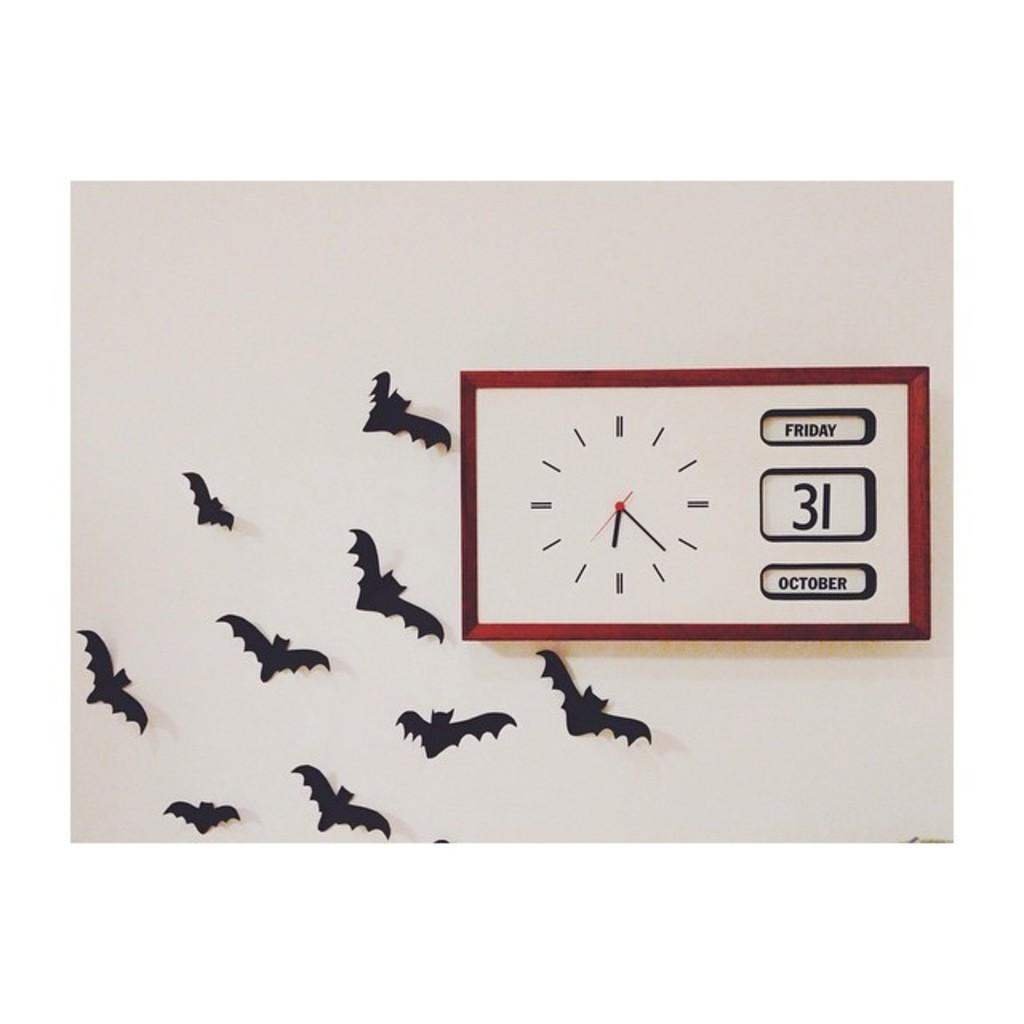<image>
Provide a brief description of the given image. a framed clock and calander that says 'friday 31 october' on it 